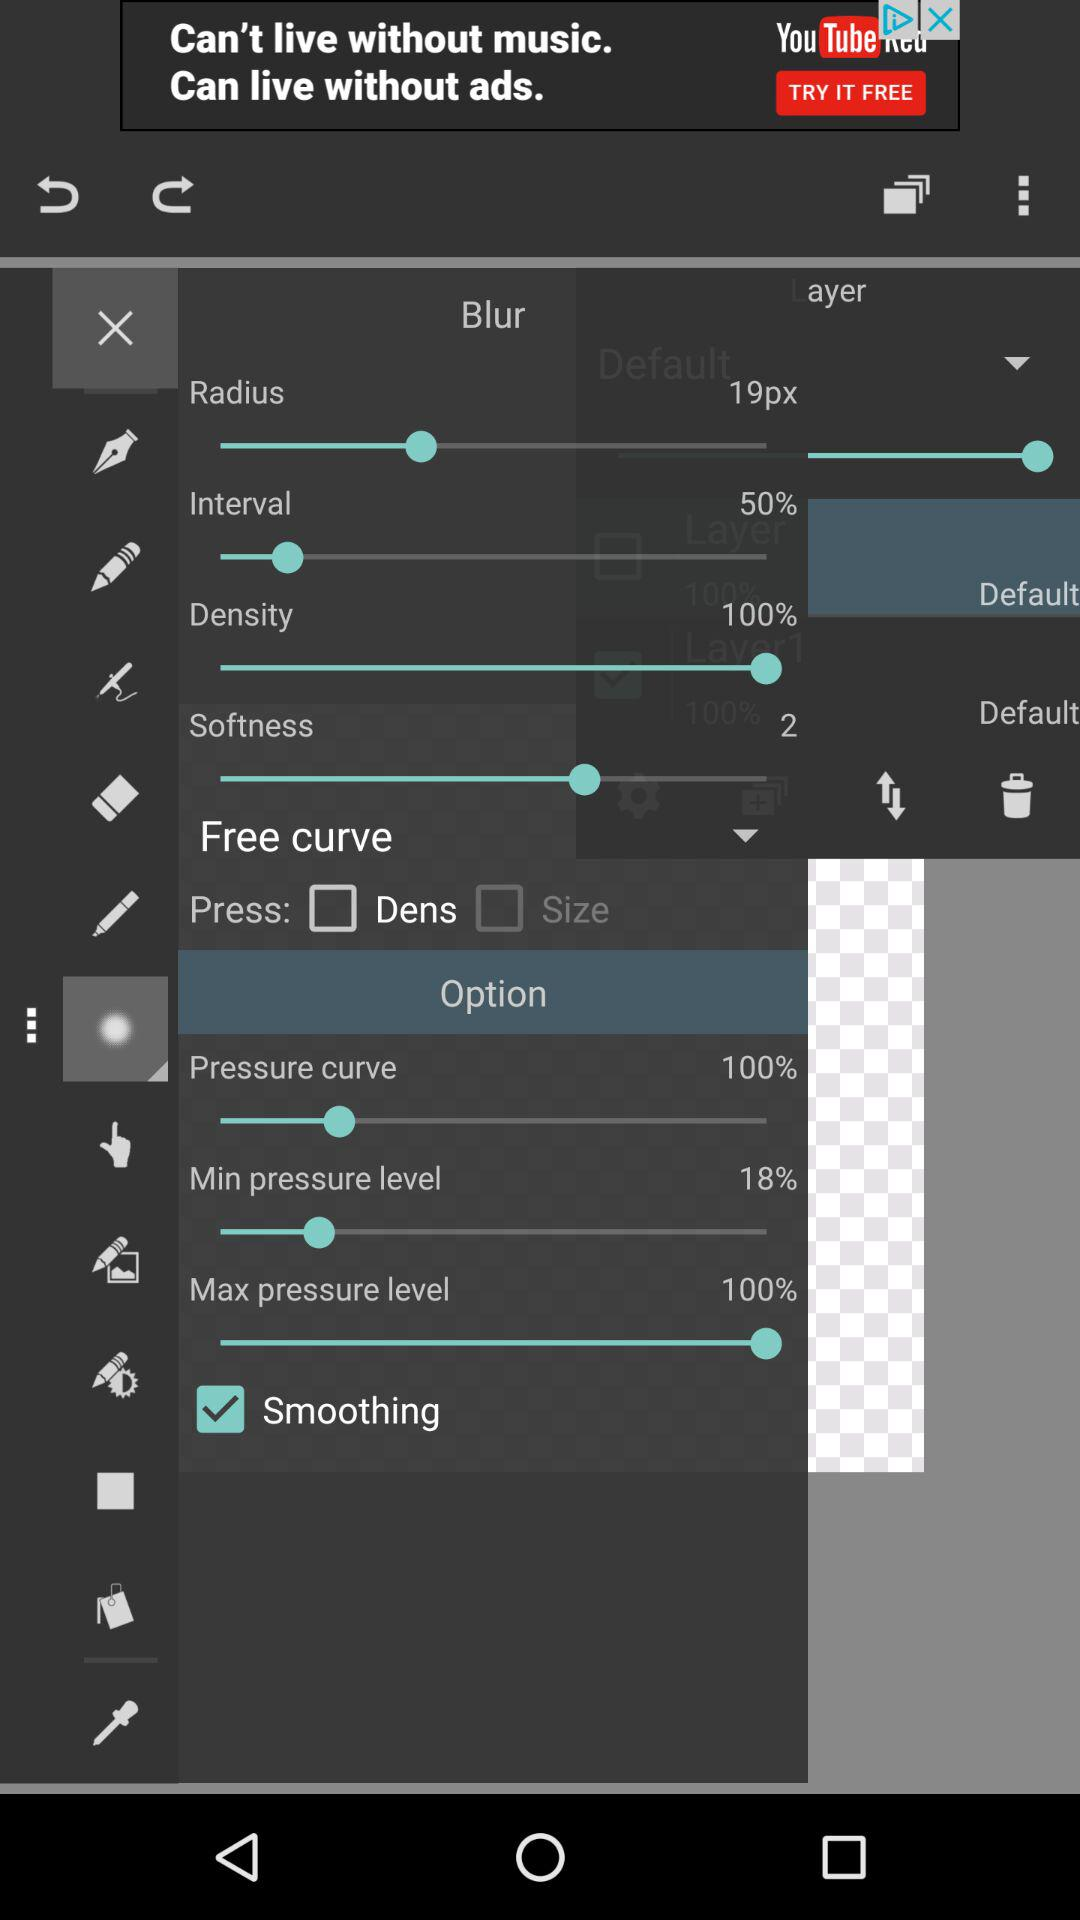What is the percentage of the minimum pressure level? The percentage of the minimum pressure level is 18. 